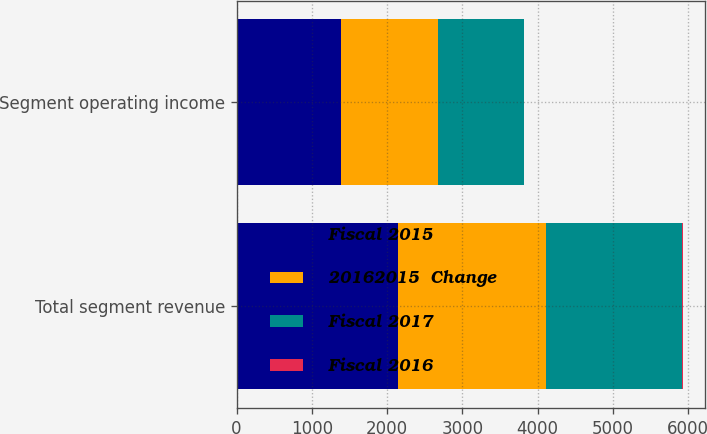<chart> <loc_0><loc_0><loc_500><loc_500><stacked_bar_chart><ecel><fcel>Total segment revenue<fcel>Segment operating income<nl><fcel>Fiscal 2015<fcel>2143<fcel>1392<nl><fcel>20162015  Change<fcel>1973<fcel>1289<nl><fcel>Fiscal 2017<fcel>1800<fcel>1134<nl><fcel>Fiscal 2016<fcel>9<fcel>8<nl></chart> 